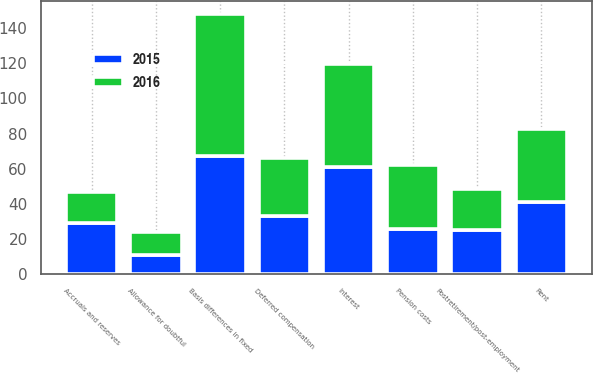Convert chart to OTSL. <chart><loc_0><loc_0><loc_500><loc_500><stacked_bar_chart><ecel><fcel>Postretirement/post-employment<fcel>Deferred compensation<fcel>Pension costs<fcel>Basis differences in fixed<fcel>Rent<fcel>Interest<fcel>Accruals and reserves<fcel>Allowance for doubtful<nl><fcel>2016<fcel>23.1<fcel>33<fcel>36.6<fcel>80.2<fcel>41.7<fcel>58.9<fcel>17.2<fcel>13.3<nl><fcel>2015<fcel>25.3<fcel>33<fcel>25.8<fcel>67.5<fcel>41.1<fcel>60.9<fcel>29.4<fcel>10.8<nl></chart> 